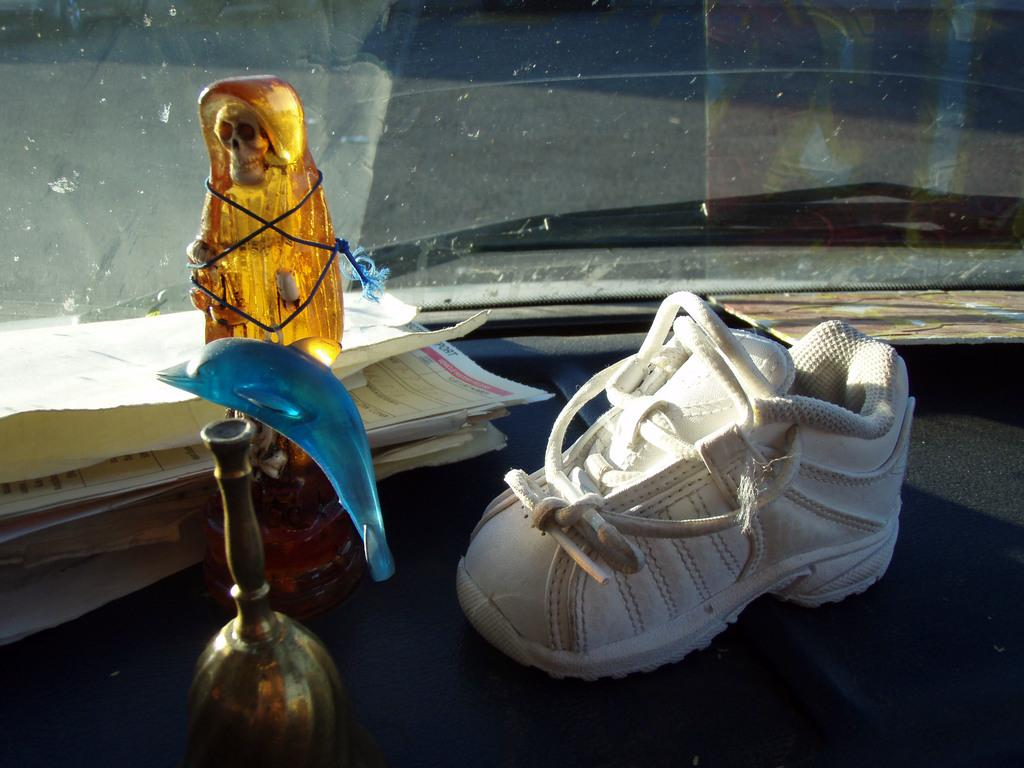What type of shoe is visible in the image? There is a white shoe in the image. What is the shoe resting on? The shoe is on an object. What is placed in front of the shoe? There are papers and other items in front of the shoe. What is located behind the shoe? There is a glass behind the shoe. How does the flock of birds interact with the shoe in the image? There are no birds present in the image, so a flock of birds cannot interact with the shoe. 